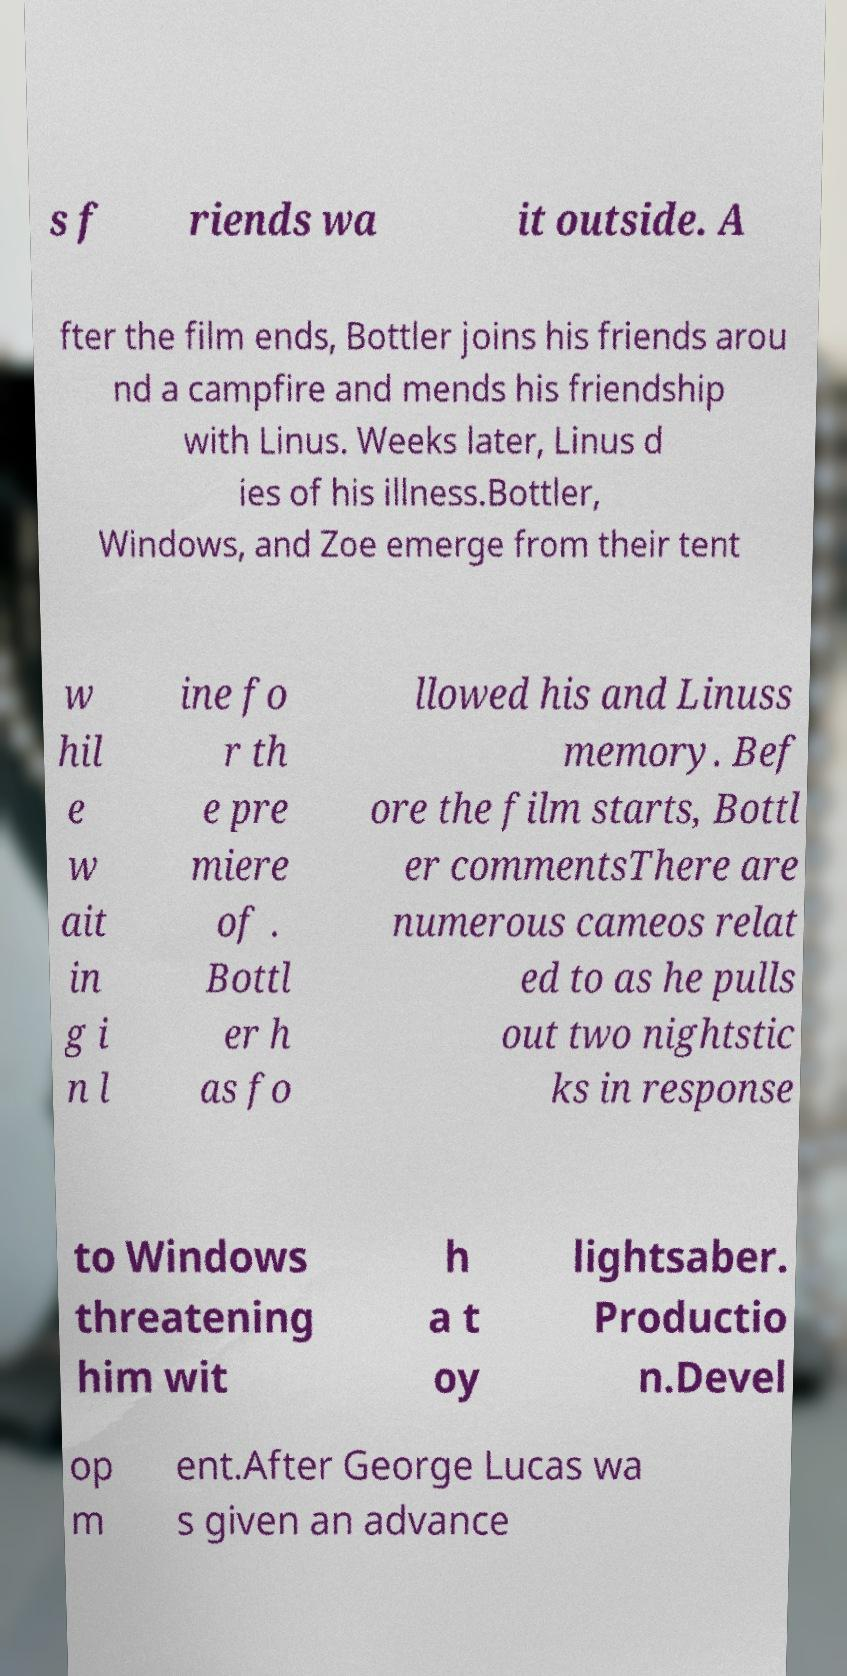Could you assist in decoding the text presented in this image and type it out clearly? s f riends wa it outside. A fter the film ends, Bottler joins his friends arou nd a campfire and mends his friendship with Linus. Weeks later, Linus d ies of his illness.Bottler, Windows, and Zoe emerge from their tent w hil e w ait in g i n l ine fo r th e pre miere of . Bottl er h as fo llowed his and Linuss memory. Bef ore the film starts, Bottl er commentsThere are numerous cameos relat ed to as he pulls out two nightstic ks in response to Windows threatening him wit h a t oy lightsaber. Productio n.Devel op m ent.After George Lucas wa s given an advance 